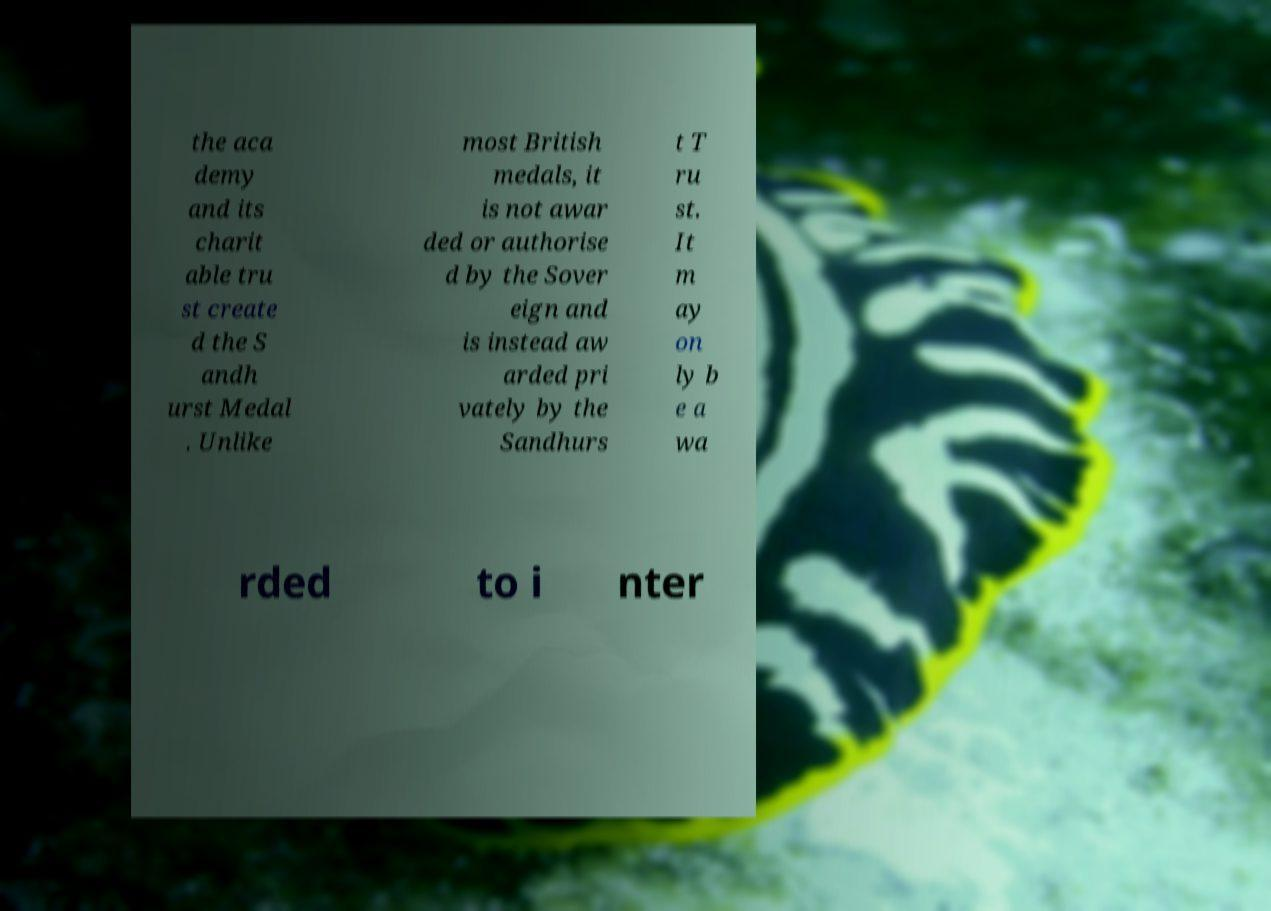Could you extract and type out the text from this image? the aca demy and its charit able tru st create d the S andh urst Medal . Unlike most British medals, it is not awar ded or authorise d by the Sover eign and is instead aw arded pri vately by the Sandhurs t T ru st. It m ay on ly b e a wa rded to i nter 